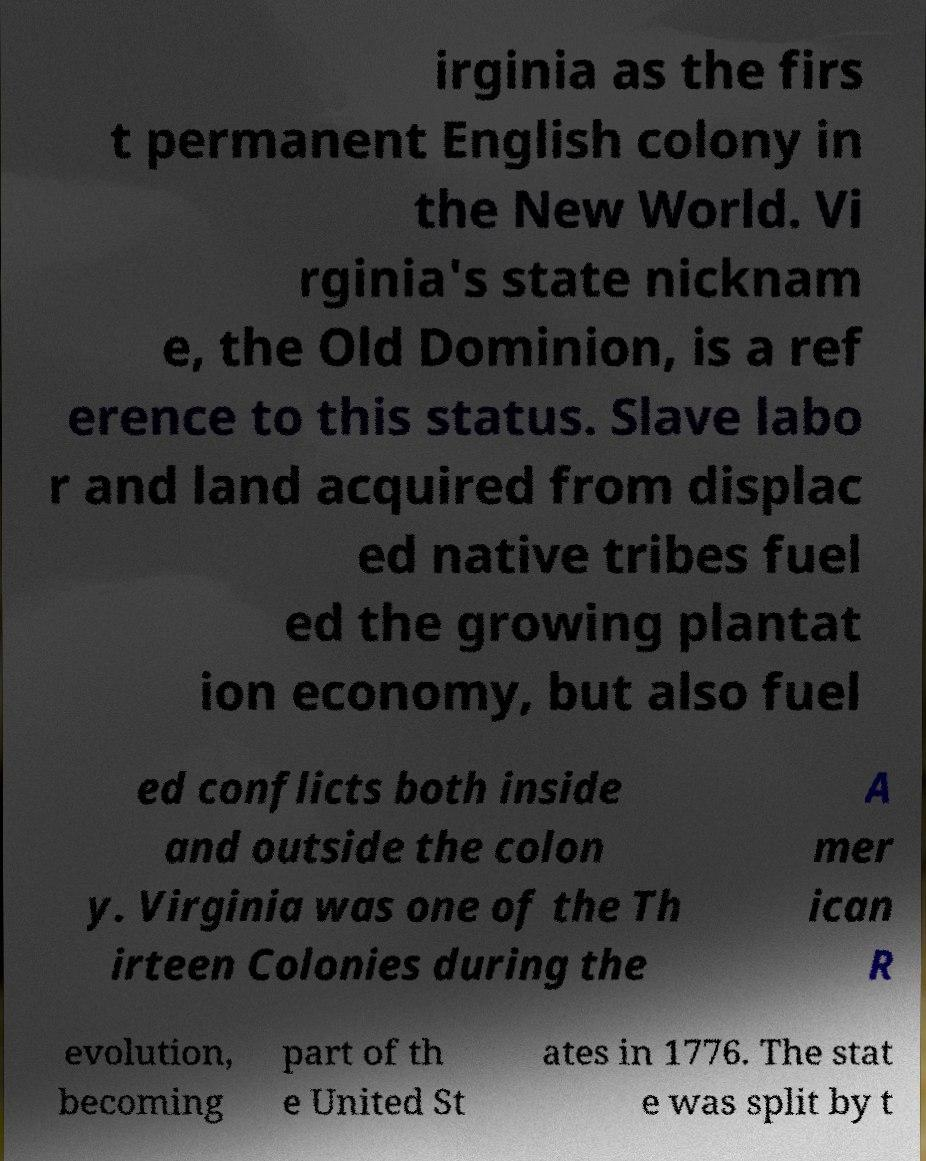Could you extract and type out the text from this image? irginia as the firs t permanent English colony in the New World. Vi rginia's state nicknam e, the Old Dominion, is a ref erence to this status. Slave labo r and land acquired from displac ed native tribes fuel ed the growing plantat ion economy, but also fuel ed conflicts both inside and outside the colon y. Virginia was one of the Th irteen Colonies during the A mer ican R evolution, becoming part of th e United St ates in 1776. The stat e was split by t 